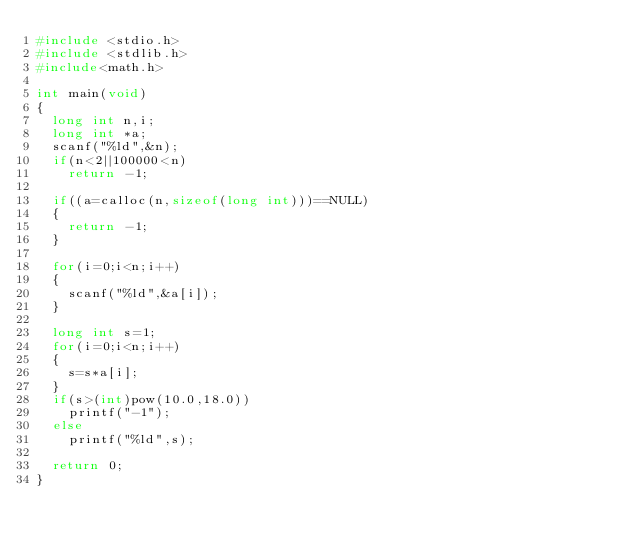Convert code to text. <code><loc_0><loc_0><loc_500><loc_500><_C_>#include <stdio.h>
#include <stdlib.h>
#include<math.h>

int main(void)
{
  long int n,i;
  long int *a;
  scanf("%ld",&n);
  if(n<2||100000<n)
    return -1;
  
  if((a=calloc(n,sizeof(long int)))==NULL)
  {
    return -1;
  }
    
  for(i=0;i<n;i++)
  {
    scanf("%ld",&a[i]);
  }
  
  long int s=1;
  for(i=0;i<n;i++)
  {
    s=s*a[i];
  }
  if(s>(int)pow(10.0,18.0))
    printf("-1");
  else
  	printf("%ld",s);
  
  return 0;
}
  </code> 